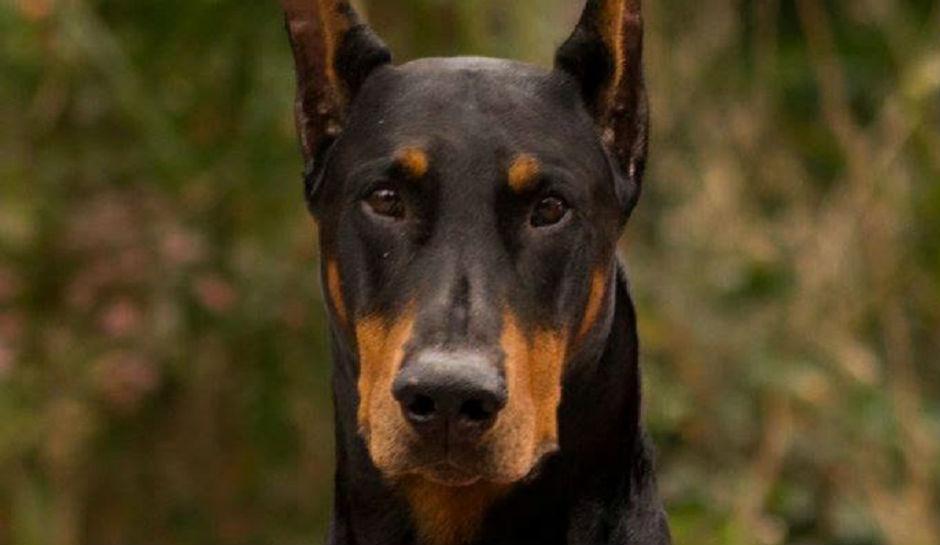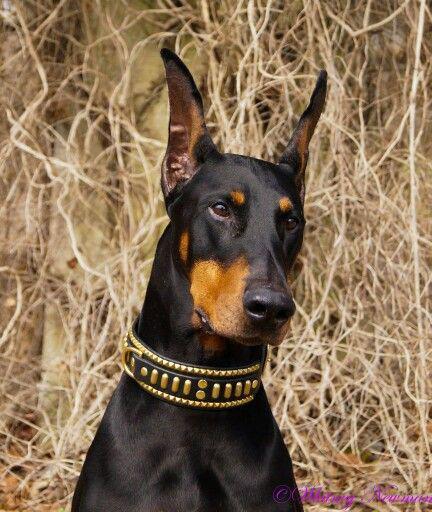The first image is the image on the left, the second image is the image on the right. For the images shown, is this caption "One image shows a camera-gazing doberman with a blue tag dangling from its collar and stubby-looking ears." true? Answer yes or no. No. The first image is the image on the left, the second image is the image on the right. For the images displayed, is the sentence "There are two dogs." factually correct? Answer yes or no. Yes. 